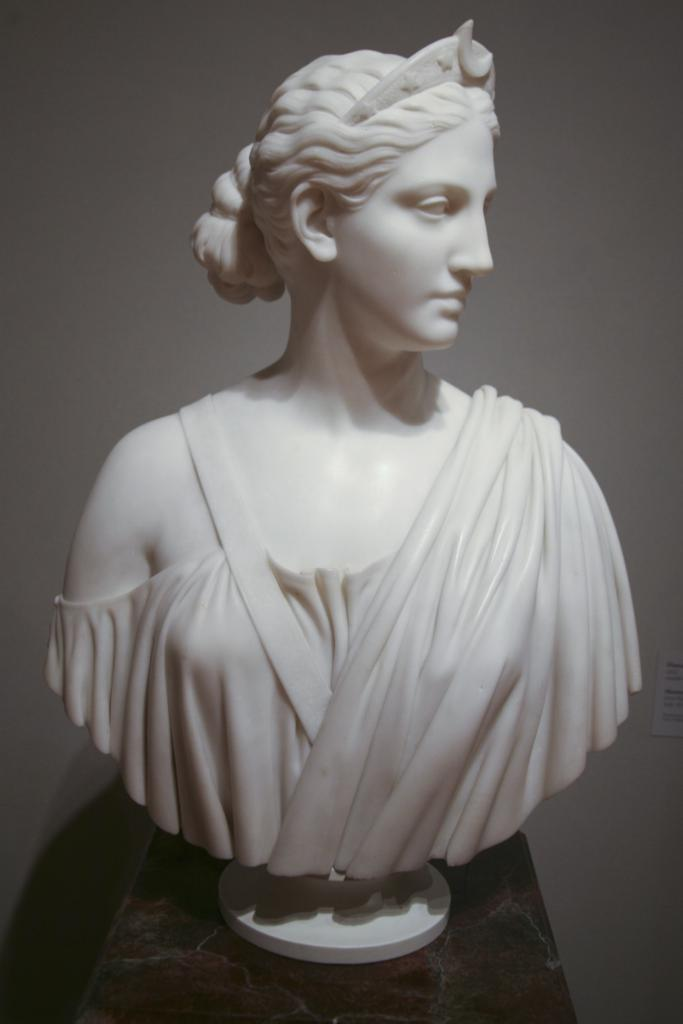What is the main subject in the foreground of the image? There is a sculpture in the foreground of the image. What is the sculpture resting on? The sculpture is on a stone surface. What can be seen in the background of the image? There is a white wall in the background of the image. How many toes are visible on the sculpture in the image? There are no visible toes on the sculpture in the image, as it is a sculpture and not a living being. 